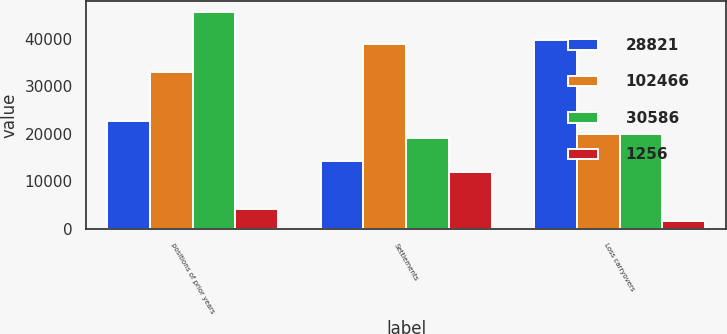<chart> <loc_0><loc_0><loc_500><loc_500><stacked_bar_chart><ecel><fcel>positions of prior years<fcel>Settlements<fcel>Loss carryovers<nl><fcel>28821<fcel>22830<fcel>14247<fcel>39847<nl><fcel>102466<fcel>33000<fcel>38969<fcel>20031<nl><fcel>30586<fcel>45613<fcel>19056<fcel>20031<nl><fcel>1256<fcel>4235<fcel>11891<fcel>1618<nl></chart> 